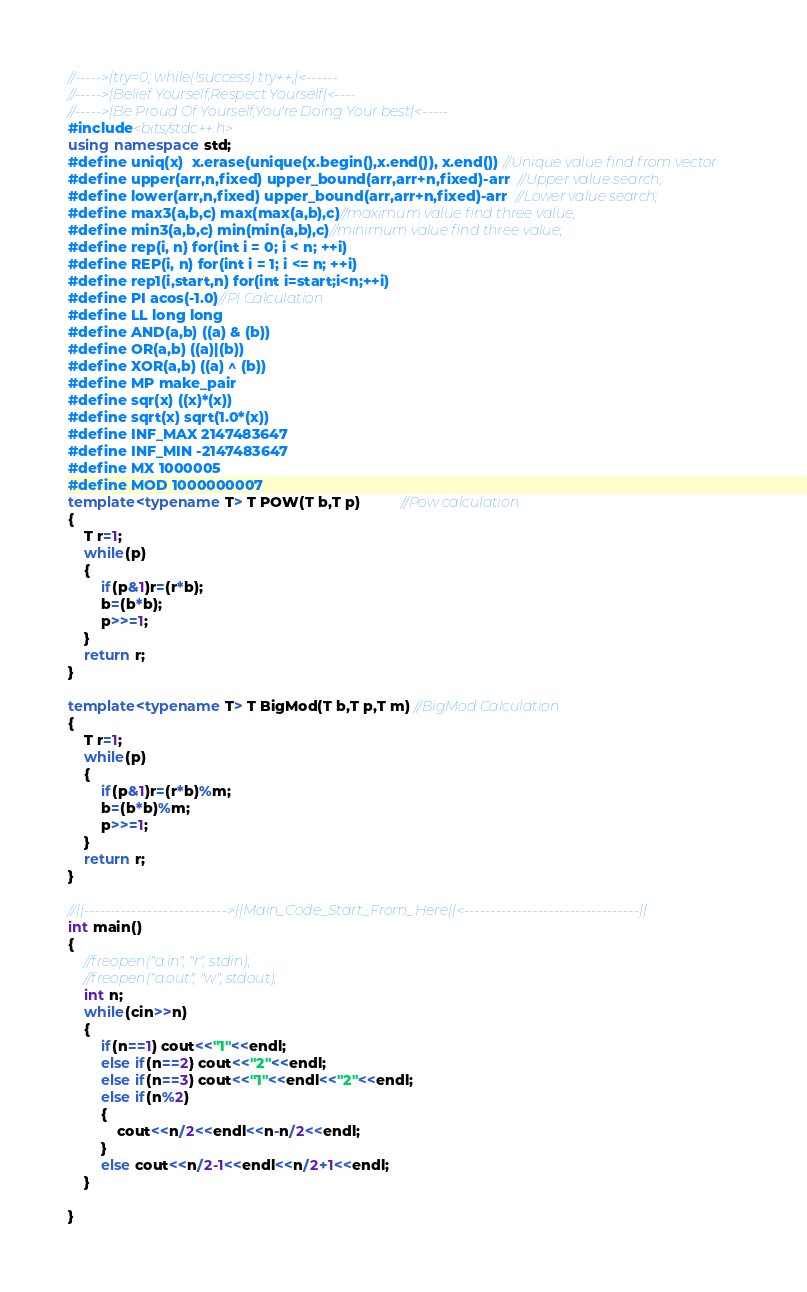Convert code to text. <code><loc_0><loc_0><loc_500><loc_500><_C++_>//----->|try=0; while(!success) try++;|<------
//----->|Belief Yourself,Respect Yourself|<----
//----->|Be Proud Of Yourself,You're Doing Your best|<-----
#include<bits/stdc++.h>
using namespace std;
#define uniq(x)  x.erase(unique(x.begin(),x.end()), x.end()) //Unique value find from vector
#define upper(arr,n,fixed) upper_bound(arr,arr+n,fixed)-arr  //Upper value search;
#define lower(arr,n,fixed) upper_bound(arr,arr+n,fixed)-arr  //Lower value search;
#define max3(a,b,c) max(max(a,b),c)//maximum value find three value;
#define min3(a,b,c) min(min(a,b),c)//minimum value find three value;
#define rep(i, n) for(int i = 0; i < n; ++i)
#define REP(i, n) for(int i = 1; i <= n; ++i)
#define rep1(i,start,n) for(int i=start;i<n;++i)
#define PI acos(-1.0)//PI Calculation
#define LL long long
#define AND(a,b) ((a) & (b))
#define OR(a,b) ((a)|(b))
#define XOR(a,b) ((a) ^ (b))
#define MP make_pair
#define sqr(x) ((x)*(x))
#define sqrt(x) sqrt(1.0*(x))
#define INF_MAX 2147483647
#define INF_MIN -2147483647
#define MX 1000005
#define MOD 1000000007
template<typename T> T POW(T b,T p)          //Pow calculation
{
    T r=1;
    while(p)
    {
        if(p&1)r=(r*b);
        b=(b*b);
        p>>=1;
    }
    return r;
}

template<typename T> T BigMod(T b,T p,T m) //BigMod Calculation
{
    T r=1;
    while(p)
    {
        if(p&1)r=(r*b)%m;
        b=(b*b)%m;
        p>>=1;
    }
    return r;
}

//||--------------------------->||Main_Code_Start_From_Here||<---------------------------------||
int main()
{
    //freopen("a.in", "r", stdin);
    //freopen("a.out", "w", stdout);
    int n;
    while(cin>>n)
    {
        if(n==1) cout<<"1"<<endl;
        else if(n==2) cout<<"2"<<endl;
        else if(n==3) cout<<"1"<<endl<<"2"<<endl;
        else if(n%2)
        {
            cout<<n/2<<endl<<n-n/2<<endl;
        }
        else cout<<n/2-1<<endl<<n/2+1<<endl;
    }

}

</code> 